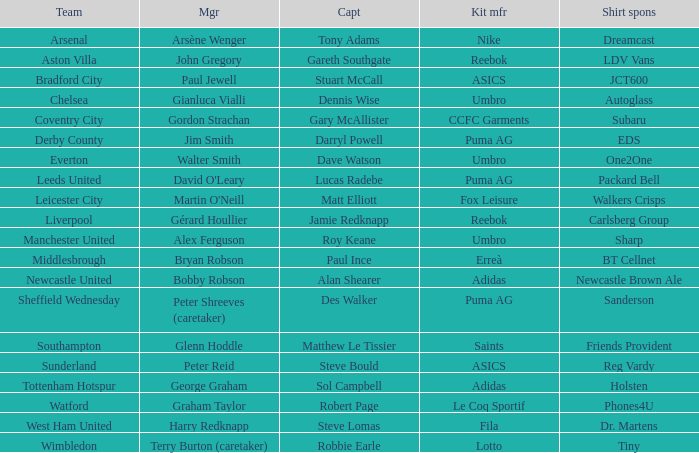Which kit maker supports arsenal through sponsorship? Nike. 